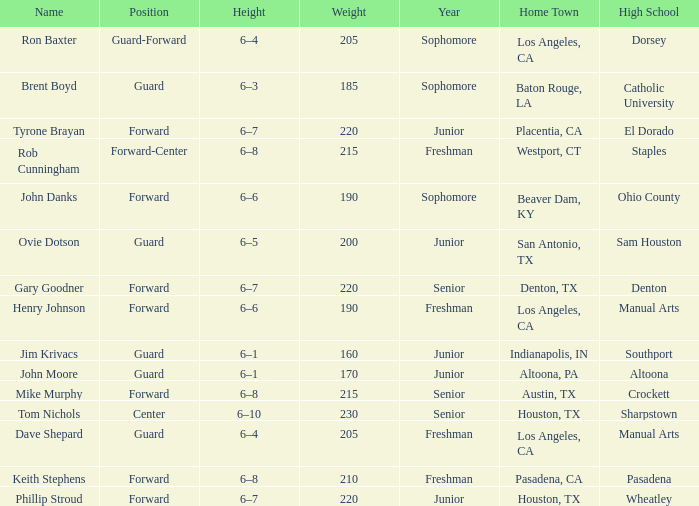What is the role in a year with a first-year student, and a weight exceeding 210? Forward-Center. 